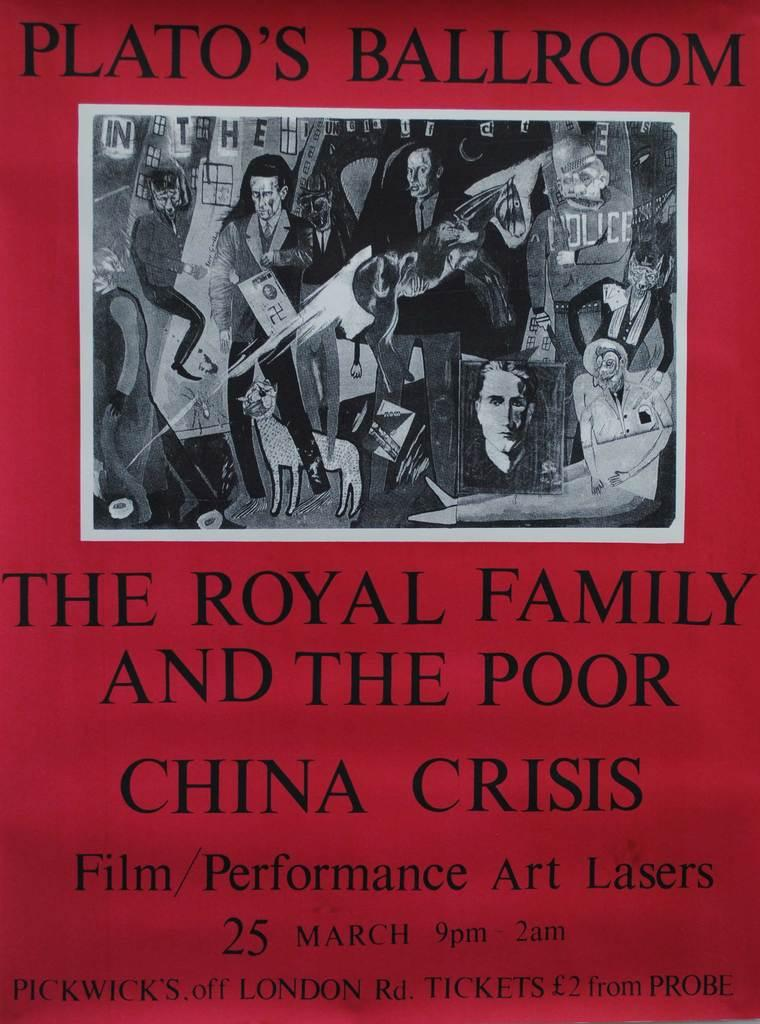What is present in the image that contains an image and text? There is a poster in the image that contains an image and text. What type of image is on the poster? The image on the poster includes cartoons of some persons. Can you describe the content of the poster? The poster contains an image and text, with the image featuring cartoons of some persons. Is there a ghost visible in the image? No, there is no ghost present in the image. The image on the poster includes cartoons of some persons, but no ghosts are depicted. 